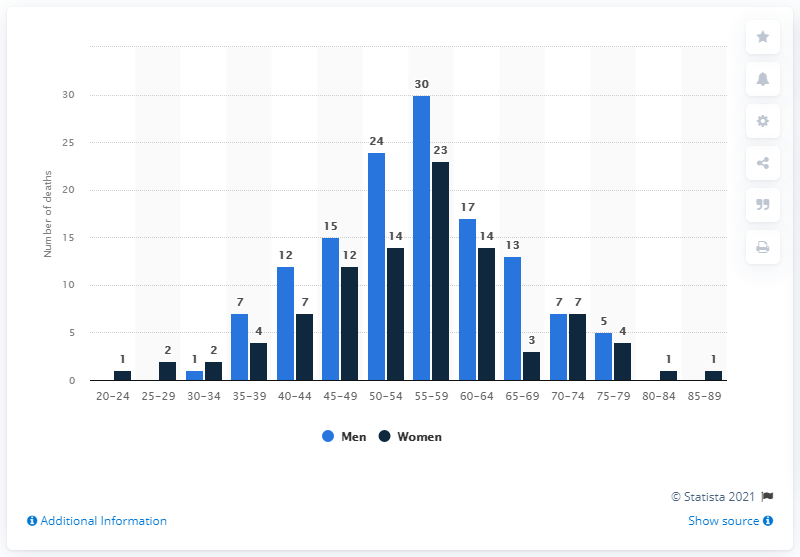Identify some key points in this picture. In 2019, 30 men in Northern Ireland died as a result of alcoholic liver disease. The two modes of women at 40-44 and 55-59 are 0.304347826... The graph displays 14 age groups, representing a diverse range of age demographics. 